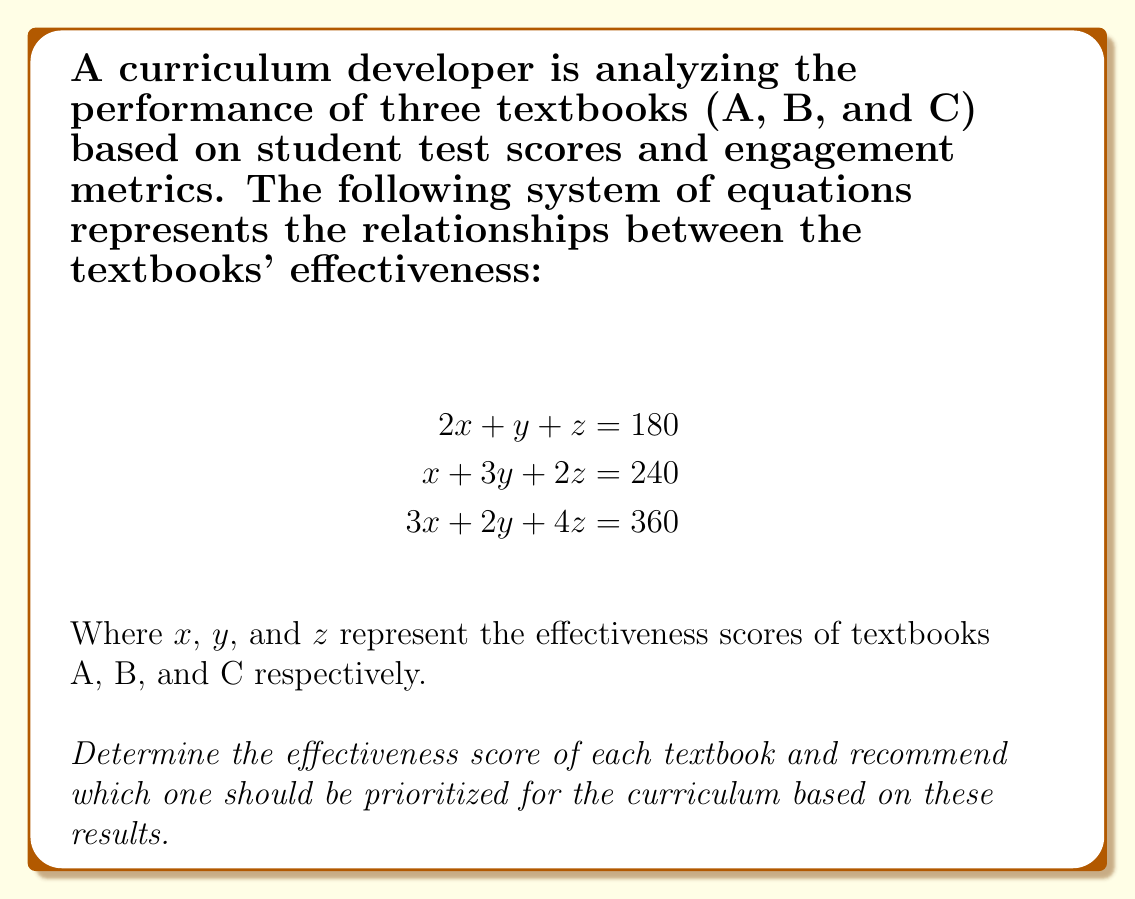Show me your answer to this math problem. To solve this system of equations, we'll use the elimination method:

1. Multiply the first equation by 3 and the second equation by -2:
   $$\begin{align}
   6x + 3y + 3z &= 540 \\
   -2x - 6y - 4z &= -480
   \end{align}$$

2. Add these equations to eliminate x:
   $$4y - z = 60 \quad \text{(Equation 4)}$$

3. Multiply the first equation by 3 and the third equation by -2:
   $$\begin{align}
   6x + 3y + 3z &= 540 \\
   -6x - 4y - 8z &= -720
   \end{align}$$

4. Add these equations to eliminate x:
   $$-y - 5z = -180 \quad \text{(Equation 5)}$$

5. Multiply Equation 4 by 5 and Equation 5 by -1:
   $$\begin{align}
   20y - 5z &= 300 \\
   y + 5z &= 180
   \end{align}$$

6. Add these equations:
   $$21y = 480$$
   $$y = \frac{480}{21} \approx 22.86$$

7. Substitute y into Equation 4:
   $$4(22.86) - z = 60$$
   $$z = 31.44$$

8. Substitute y and z into the first original equation:
   $$2x + 22.86 + 31.44 = 180$$
   $$2x = 125.7$$
   $$x = 62.85$$

Therefore, the effectiveness scores are:
Textbook A (x): 62.85
Textbook B (y): 22.86
Textbook C (z): 31.44

Based on these results, Textbook A has the highest effectiveness score and should be prioritized for the curriculum.
Answer: Textbook A: 62.85
Textbook B: 22.86
Textbook C: 31.44

Recommendation: Prioritize Textbook A for the curriculum. 